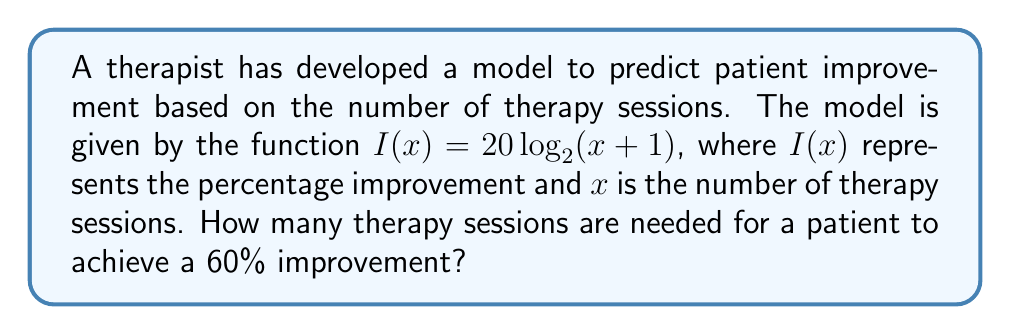Teach me how to tackle this problem. To solve this problem, we need to use the given logarithmic function and solve for $x$ when $I(x) = 60$.

1) Start with the equation:
   $60 = 20 \log_2(x + 1)$

2) Divide both sides by 20:
   $3 = \log_2(x + 1)$

3) To solve for $x$, we need to apply the inverse function (exponential) to both sides:
   $2^3 = x + 1$

4) Simplify the left side:
   $8 = x + 1$

5) Subtract 1 from both sides:
   $7 = x$

Therefore, 7 therapy sessions are needed for a patient to achieve a 60% improvement according to this model.
Answer: 7 sessions 